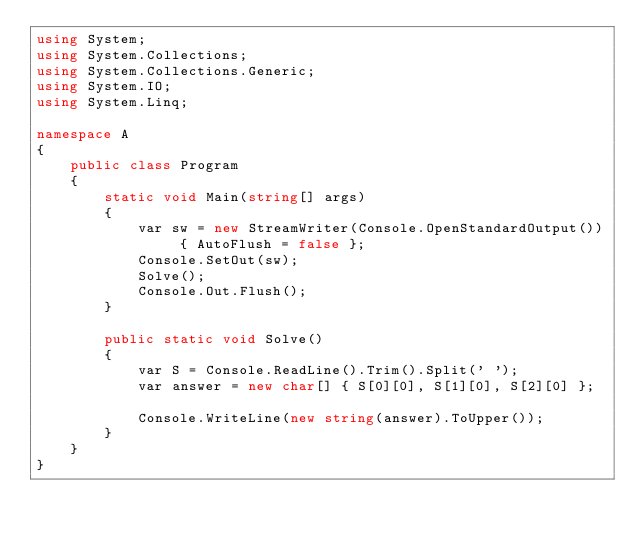Convert code to text. <code><loc_0><loc_0><loc_500><loc_500><_C#_>using System;
using System.Collections;
using System.Collections.Generic;
using System.IO;
using System.Linq;

namespace A
{
    public class Program
    {
        static void Main(string[] args)
        {
            var sw = new StreamWriter(Console.OpenStandardOutput()) { AutoFlush = false };
            Console.SetOut(sw);
            Solve();
            Console.Out.Flush();
        }

        public static void Solve()
        {
            var S = Console.ReadLine().Trim().Split(' ');
            var answer = new char[] { S[0][0], S[1][0], S[2][0] };

            Console.WriteLine(new string(answer).ToUpper());
        }
    }
}
</code> 